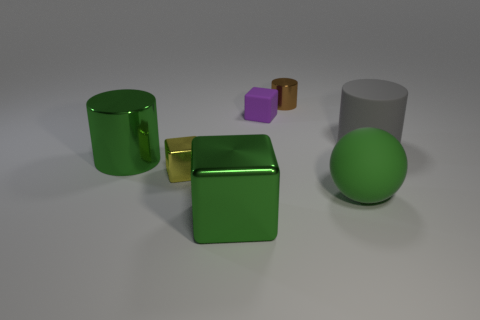Subtract all small cylinders. How many cylinders are left? 2 Add 1 large objects. How many objects exist? 8 Subtract all yellow cubes. How many cubes are left? 2 Subtract all cylinders. How many objects are left? 4 Add 5 shiny things. How many shiny things are left? 9 Add 5 big brown cylinders. How many big brown cylinders exist? 5 Subtract 1 gray cylinders. How many objects are left? 6 Subtract 1 balls. How many balls are left? 0 Subtract all red blocks. Subtract all green balls. How many blocks are left? 3 Subtract all cyan cubes. How many gray cylinders are left? 1 